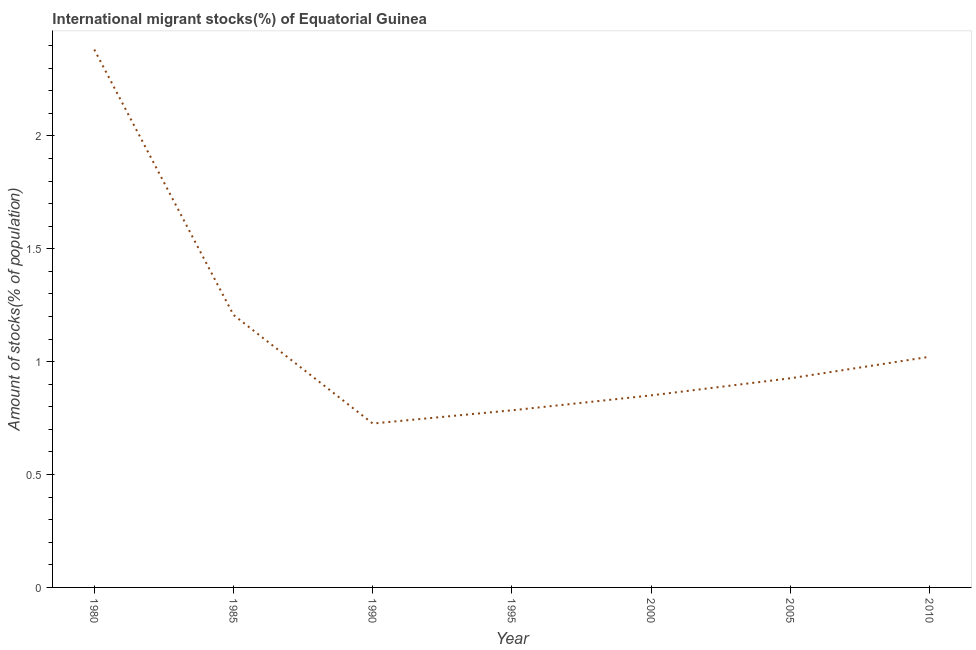What is the number of international migrant stocks in 1980?
Keep it short and to the point. 2.38. Across all years, what is the maximum number of international migrant stocks?
Your answer should be very brief. 2.38. Across all years, what is the minimum number of international migrant stocks?
Offer a terse response. 0.73. What is the sum of the number of international migrant stocks?
Your response must be concise. 7.9. What is the difference between the number of international migrant stocks in 1995 and 2005?
Your answer should be compact. -0.14. What is the average number of international migrant stocks per year?
Provide a short and direct response. 1.13. What is the median number of international migrant stocks?
Your answer should be compact. 0.93. In how many years, is the number of international migrant stocks greater than 2 %?
Keep it short and to the point. 1. What is the ratio of the number of international migrant stocks in 1990 to that in 1995?
Provide a short and direct response. 0.93. What is the difference between the highest and the second highest number of international migrant stocks?
Offer a terse response. 1.18. What is the difference between the highest and the lowest number of international migrant stocks?
Offer a terse response. 1.66. How many lines are there?
Offer a very short reply. 1. How many years are there in the graph?
Your answer should be very brief. 7. What is the difference between two consecutive major ticks on the Y-axis?
Your answer should be very brief. 0.5. What is the title of the graph?
Provide a succinct answer. International migrant stocks(%) of Equatorial Guinea. What is the label or title of the X-axis?
Your answer should be very brief. Year. What is the label or title of the Y-axis?
Provide a short and direct response. Amount of stocks(% of population). What is the Amount of stocks(% of population) of 1980?
Provide a succinct answer. 2.38. What is the Amount of stocks(% of population) in 1985?
Offer a very short reply. 1.21. What is the Amount of stocks(% of population) of 1990?
Ensure brevity in your answer.  0.73. What is the Amount of stocks(% of population) of 1995?
Offer a very short reply. 0.78. What is the Amount of stocks(% of population) in 2000?
Make the answer very short. 0.85. What is the Amount of stocks(% of population) in 2005?
Your answer should be very brief. 0.93. What is the Amount of stocks(% of population) of 2010?
Provide a short and direct response. 1.02. What is the difference between the Amount of stocks(% of population) in 1980 and 1985?
Ensure brevity in your answer.  1.18. What is the difference between the Amount of stocks(% of population) in 1980 and 1990?
Give a very brief answer. 1.66. What is the difference between the Amount of stocks(% of population) in 1980 and 1995?
Ensure brevity in your answer.  1.6. What is the difference between the Amount of stocks(% of population) in 1980 and 2000?
Make the answer very short. 1.53. What is the difference between the Amount of stocks(% of population) in 1980 and 2005?
Offer a very short reply. 1.46. What is the difference between the Amount of stocks(% of population) in 1980 and 2010?
Provide a succinct answer. 1.36. What is the difference between the Amount of stocks(% of population) in 1985 and 1990?
Offer a terse response. 0.48. What is the difference between the Amount of stocks(% of population) in 1985 and 1995?
Offer a terse response. 0.42. What is the difference between the Amount of stocks(% of population) in 1985 and 2000?
Give a very brief answer. 0.36. What is the difference between the Amount of stocks(% of population) in 1985 and 2005?
Make the answer very short. 0.28. What is the difference between the Amount of stocks(% of population) in 1985 and 2010?
Provide a short and direct response. 0.19. What is the difference between the Amount of stocks(% of population) in 1990 and 1995?
Offer a terse response. -0.06. What is the difference between the Amount of stocks(% of population) in 1990 and 2000?
Keep it short and to the point. -0.12. What is the difference between the Amount of stocks(% of population) in 1990 and 2005?
Your answer should be compact. -0.2. What is the difference between the Amount of stocks(% of population) in 1990 and 2010?
Your response must be concise. -0.3. What is the difference between the Amount of stocks(% of population) in 1995 and 2000?
Provide a succinct answer. -0.07. What is the difference between the Amount of stocks(% of population) in 1995 and 2005?
Offer a terse response. -0.14. What is the difference between the Amount of stocks(% of population) in 1995 and 2010?
Provide a short and direct response. -0.24. What is the difference between the Amount of stocks(% of population) in 2000 and 2005?
Ensure brevity in your answer.  -0.08. What is the difference between the Amount of stocks(% of population) in 2000 and 2010?
Provide a short and direct response. -0.17. What is the difference between the Amount of stocks(% of population) in 2005 and 2010?
Provide a succinct answer. -0.1. What is the ratio of the Amount of stocks(% of population) in 1980 to that in 1985?
Keep it short and to the point. 1.97. What is the ratio of the Amount of stocks(% of population) in 1980 to that in 1990?
Provide a succinct answer. 3.28. What is the ratio of the Amount of stocks(% of population) in 1980 to that in 1995?
Make the answer very short. 3.04. What is the ratio of the Amount of stocks(% of population) in 1980 to that in 2000?
Offer a very short reply. 2.8. What is the ratio of the Amount of stocks(% of population) in 1980 to that in 2005?
Make the answer very short. 2.57. What is the ratio of the Amount of stocks(% of population) in 1980 to that in 2010?
Give a very brief answer. 2.33. What is the ratio of the Amount of stocks(% of population) in 1985 to that in 1990?
Your answer should be compact. 1.66. What is the ratio of the Amount of stocks(% of population) in 1985 to that in 1995?
Keep it short and to the point. 1.54. What is the ratio of the Amount of stocks(% of population) in 1985 to that in 2000?
Offer a terse response. 1.42. What is the ratio of the Amount of stocks(% of population) in 1985 to that in 2005?
Make the answer very short. 1.3. What is the ratio of the Amount of stocks(% of population) in 1985 to that in 2010?
Your answer should be very brief. 1.18. What is the ratio of the Amount of stocks(% of population) in 1990 to that in 1995?
Provide a short and direct response. 0.93. What is the ratio of the Amount of stocks(% of population) in 1990 to that in 2000?
Give a very brief answer. 0.85. What is the ratio of the Amount of stocks(% of population) in 1990 to that in 2005?
Ensure brevity in your answer.  0.78. What is the ratio of the Amount of stocks(% of population) in 1990 to that in 2010?
Ensure brevity in your answer.  0.71. What is the ratio of the Amount of stocks(% of population) in 1995 to that in 2000?
Make the answer very short. 0.92. What is the ratio of the Amount of stocks(% of population) in 1995 to that in 2005?
Offer a very short reply. 0.85. What is the ratio of the Amount of stocks(% of population) in 1995 to that in 2010?
Provide a succinct answer. 0.77. What is the ratio of the Amount of stocks(% of population) in 2000 to that in 2005?
Provide a short and direct response. 0.92. What is the ratio of the Amount of stocks(% of population) in 2000 to that in 2010?
Give a very brief answer. 0.83. What is the ratio of the Amount of stocks(% of population) in 2005 to that in 2010?
Offer a terse response. 0.91. 